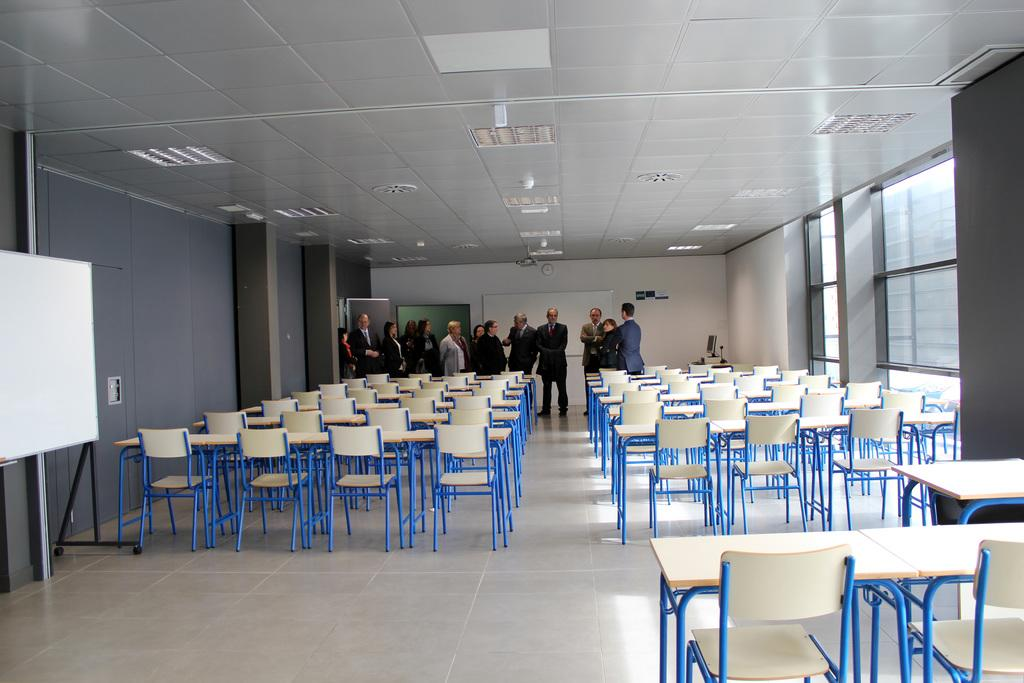What are the people in the image standing on? The persons in the image are standing on the floor. What type of furniture can be seen in the image? There are chairs in the image. What type of objects are present on the walls or ceilings? There are boards and lights in the image. What type of structure is visible in the image? There is a wall, pillars, and a roof in the image. How many apples are hanging from the roof in the image? There are no apples present in the image; it features chairs, boards, lights, a wall, pillars, and a roof. What type of coat is draped over the chair in the image? There is no coat present in the image; it only features chairs, boards, lights, a wall, pillars, and a roof. 